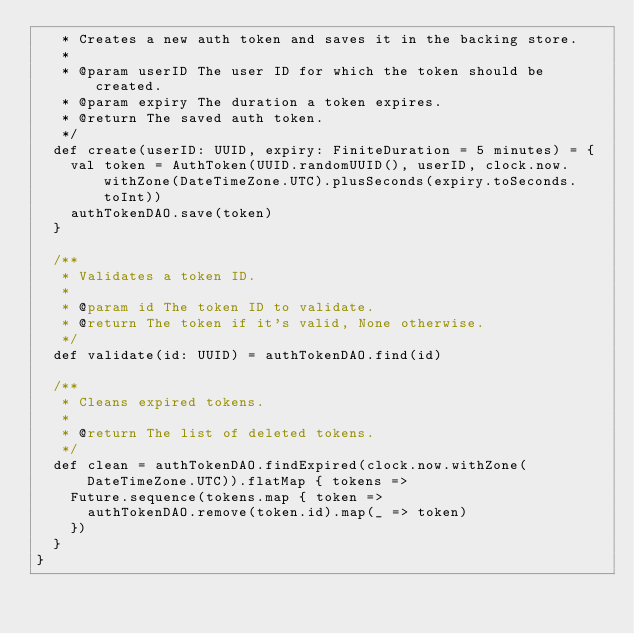Convert code to text. <code><loc_0><loc_0><loc_500><loc_500><_Scala_>   * Creates a new auth token and saves it in the backing store.
   *
   * @param userID The user ID for which the token should be created.
   * @param expiry The duration a token expires.
   * @return The saved auth token.
   */
  def create(userID: UUID, expiry: FiniteDuration = 5 minutes) = {
    val token = AuthToken(UUID.randomUUID(), userID, clock.now.withZone(DateTimeZone.UTC).plusSeconds(expiry.toSeconds.toInt))
    authTokenDAO.save(token)
  }

  /**
   * Validates a token ID.
   *
   * @param id The token ID to validate.
   * @return The token if it's valid, None otherwise.
   */
  def validate(id: UUID) = authTokenDAO.find(id)

  /**
   * Cleans expired tokens.
   *
   * @return The list of deleted tokens.
   */
  def clean = authTokenDAO.findExpired(clock.now.withZone(DateTimeZone.UTC)).flatMap { tokens =>
    Future.sequence(tokens.map { token =>
      authTokenDAO.remove(token.id).map(_ => token)
    })
  }
}
</code> 